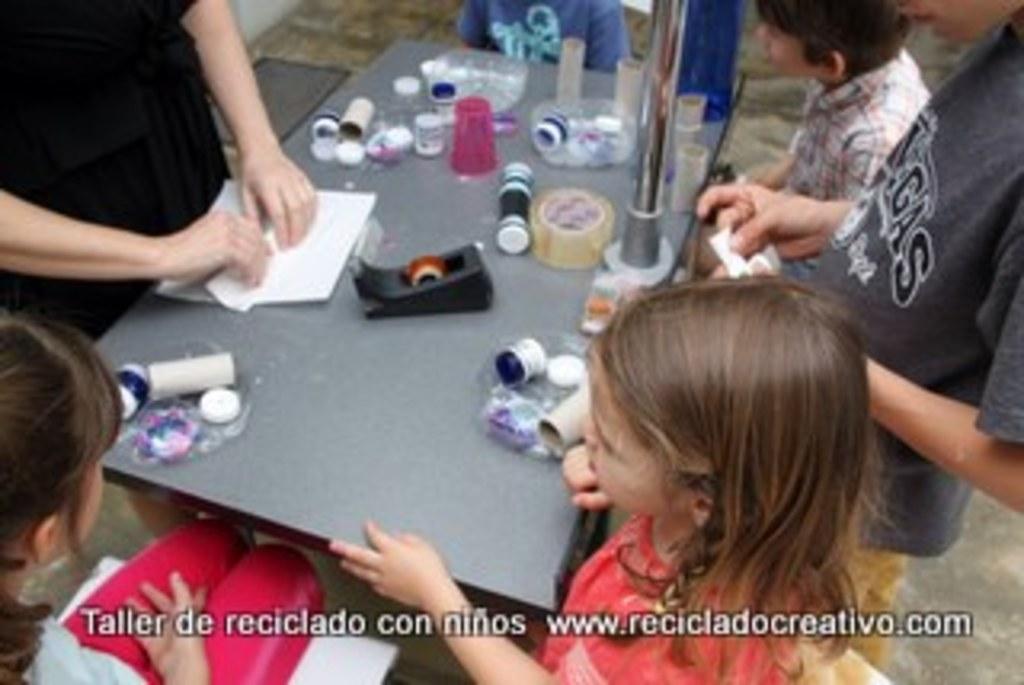How would you summarize this image in a sentence or two? This picture describes about group of people few are seated on the chair and few are standing in front of them we can see plaster, papers and some other objects on the table. 